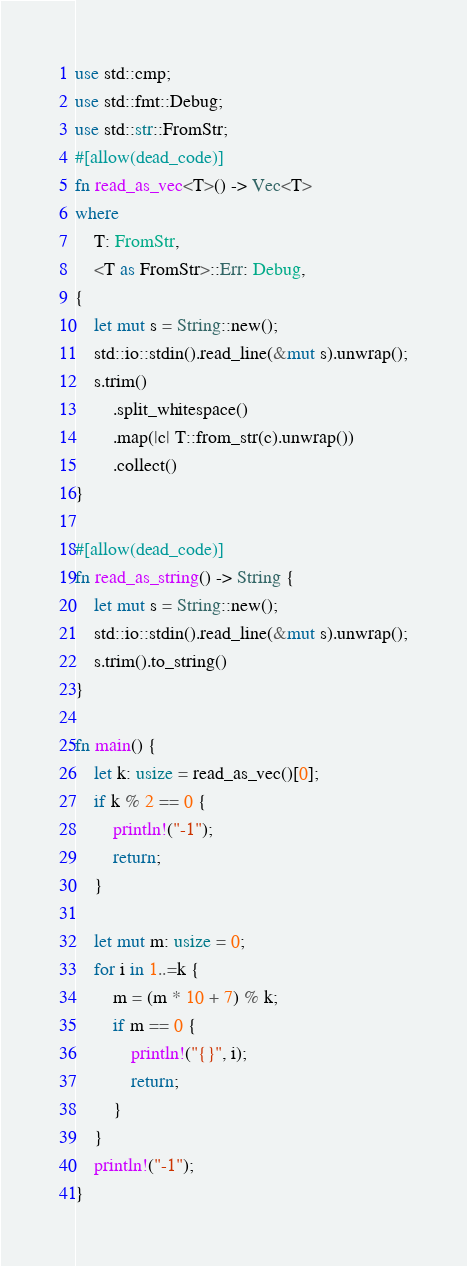Convert code to text. <code><loc_0><loc_0><loc_500><loc_500><_Rust_>use std::cmp;
use std::fmt::Debug;
use std::str::FromStr;
#[allow(dead_code)]
fn read_as_vec<T>() -> Vec<T>
where
    T: FromStr,
    <T as FromStr>::Err: Debug,
{
    let mut s = String::new();
    std::io::stdin().read_line(&mut s).unwrap();
    s.trim()
        .split_whitespace()
        .map(|c| T::from_str(c).unwrap())
        .collect()
}

#[allow(dead_code)]
fn read_as_string() -> String {
    let mut s = String::new();
    std::io::stdin().read_line(&mut s).unwrap();
    s.trim().to_string()
}

fn main() {
    let k: usize = read_as_vec()[0];
    if k % 2 == 0 {
        println!("-1");
        return;
    }

    let mut m: usize = 0;
    for i in 1..=k {
        m = (m * 10 + 7) % k;
        if m == 0 {
            println!("{}", i);
            return;
        }
    }
    println!("-1");
}
</code> 